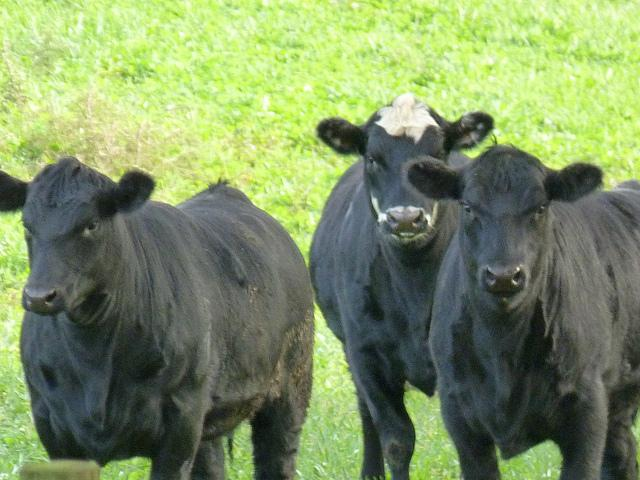What color is on the animal in the middle's head?

Choices:
A) green
B) red
C) blue
D) white white 